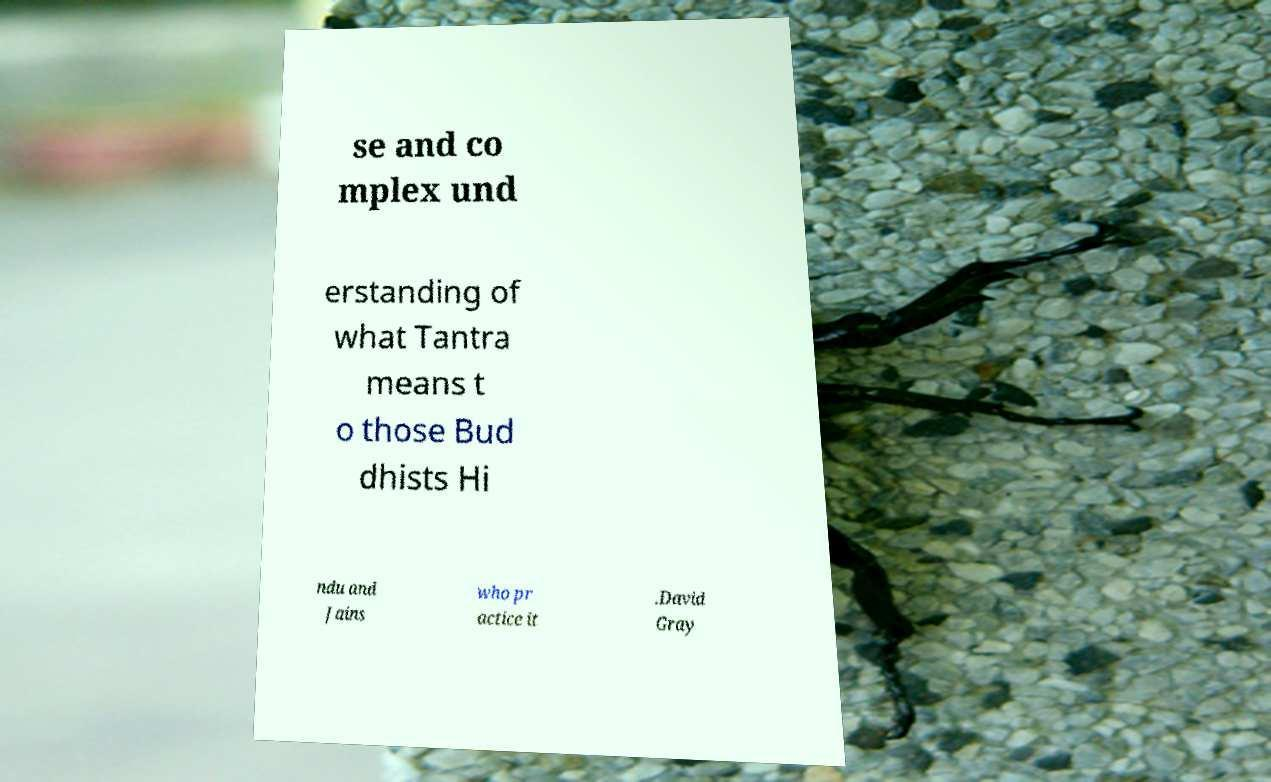For documentation purposes, I need the text within this image transcribed. Could you provide that? se and co mplex und erstanding of what Tantra means t o those Bud dhists Hi ndu and Jains who pr actice it .David Gray 